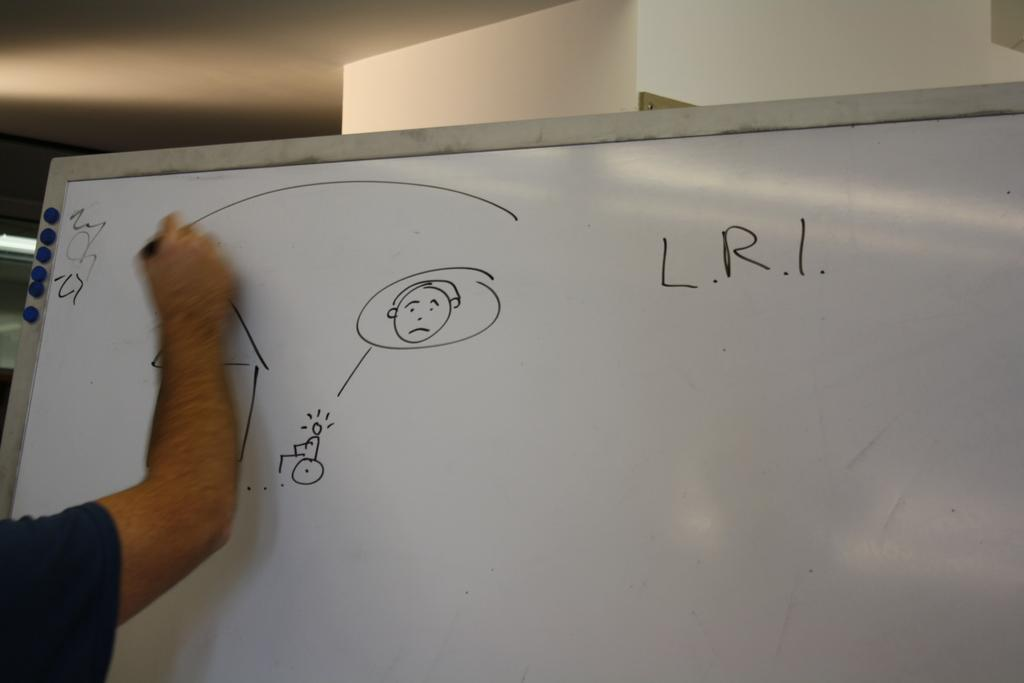What is the person in the image doing? The person is holding a marker pen and drawing on a white color board. What is the person using to draw on the color board? The person is using a marker pen. Where is the marker pen located in relation to the person? The marker pen is in the person's hand. What type of card is the governor holding in the image? There is no card or governor present in the image. 